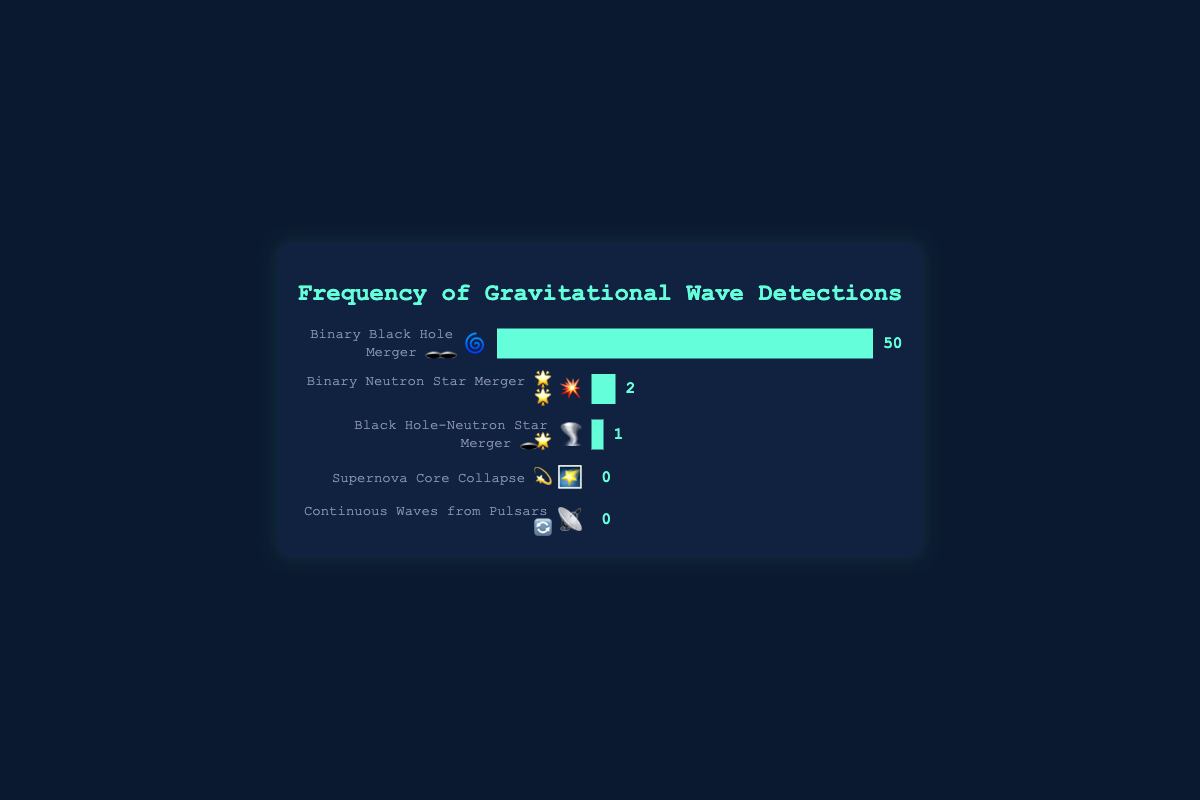Which cosmic event has the highest frequency of gravitational wave detections? The event with the highest frequency has the longest bar in the chart. The "Binary Black Hole Merger 🕳️🕳️" bar is the longest and shows a value of 50 detections.
Answer: Binary Black Hole Merger 🕳️🕳️ Which cosmic events have zero detections? The chart shows bars filled to zero width for "Supernova Core Collapse 💫" and "Continuous Waves from Pulsars 🔄" events, indicating no detections.
Answer: Supernova Core Collapse 💫, Continuous Waves from Pulsars 🔄 What is the total number of neutron star involvement events detected? There are two types of events involving neutron stars: "Binary Neutron Star Merger 🌟🌟" with 2 detections and "Black Hole-Neutron Star Merger 🕳️🌟" with 1 detection. Summing these gives 2 + 1 = 3.
Answer: 3 Which event has the lowest non-zero frequency of detections? By comparing the bars with non-zero frequencies, the "Black Hole-Neutron Star Merger 🕳️🌟" event shows the shortest bar with a frequency of 1.
Answer: Black Hole-Neutron Star Merger 🕳️🌟 How many more detections are there for Binary Black Hole Mergers compared to Binary Neutron Star Mergers? The frequency of Binary Black Hole Mergers is 50, and for Binary Neutron Star Mergers, it is 2. The difference is 50 - 2 = 48.
Answer: 48 Which event has the smallest representation on the chart? The events "Supernova Core Collapse 💫" and "Continuous Waves from Pulsars 🔄" both have bars filled to zero width, indicating the smallest representation with zero detections.
Answer: Supernova Core Collapse 💫, Continuous Waves from Pulsars 🔄 What's the average frequency of all detected events? Sum the frequencies of all events: 50 (BBH) + 2 (BNS) + 1 (BHNS) + 0 (Supernova) + 0 (Pulsars) = 53. There are 5 events in total. Therefore, the average is 53 / 5 = 10.6.
Answer: 10.6 Is the number of Binary Neutron Star Merger detections greater than the number of Black Hole-Neutron Star Merger detections? The frequency of Binary Neutron Star Mergers (2) is greater than that of Black Hole-Neutron Star Mergers (1).
Answer: Yes 